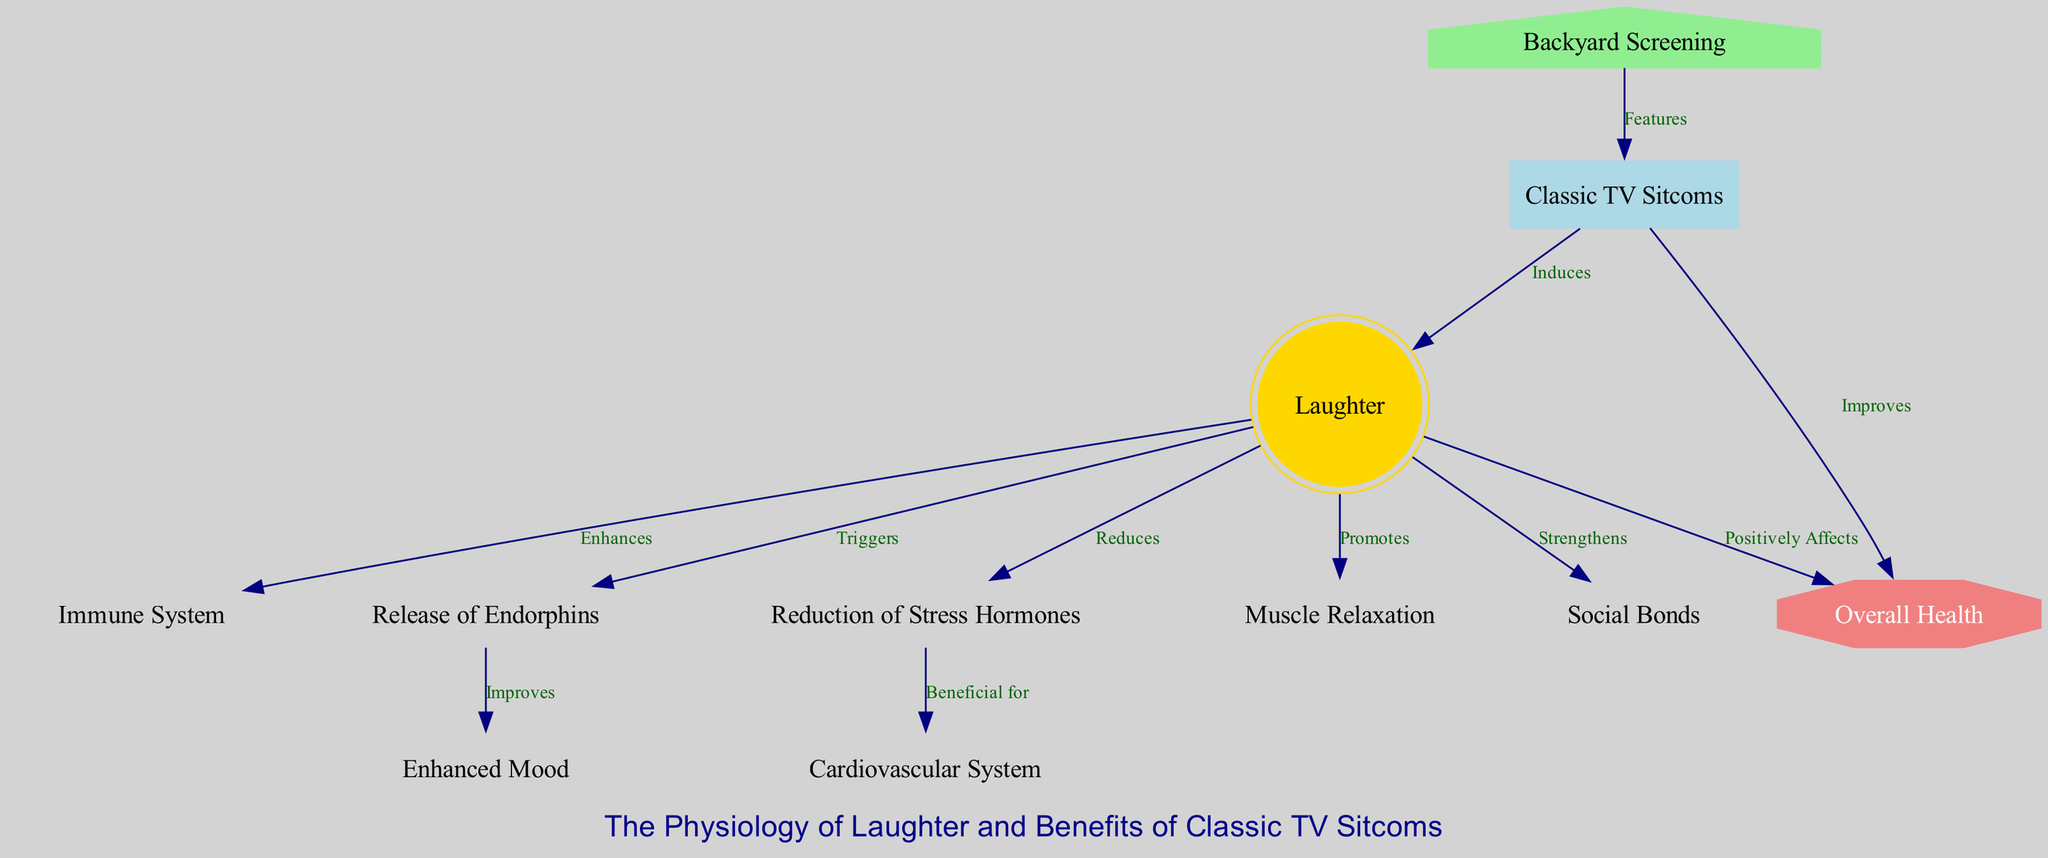What is the first node that is triggered by laughter? The diagram indicates that laughter triggers the release of endorphins, as represented by the edge from "laughter" to "endorphins."
Answer: Release of Endorphins How many total nodes are present in the diagram? By counting each node listed in the diagram, there are a total of 11 unique nodes.
Answer: 11 Which system benefits from the reduction of stress hormones? The diagram shows that stress hormones reduction is beneficial for the cardiovascular system, indicated by the edge from "stress" to "cardio."
Answer: Cardiovascular System What enhances immunity according to the diagram? As per the diagram, laughter enhances the immune system, as represented by the edge going from "laughter" to "immune."
Answer: Immune System What is the connection between classic TV sitcoms and laughter? The diagram shows that classic TV sitcoms induce laughter, represented by the edge from "sitcoms" to "laughter."
Answer: Induces Which aspect does watching classic TV sitcoms improve regarding overall health? The diagram indicates that classic TV sitcoms improve overall health, as shown by the edge from "sitcoms" to "overall_health."
Answer: Improves How does laughter affect social bonds? The diagram illustrates that laughter strengthens social bonds, indicated by the edge connecting "laughter" to "social."
Answer: Strengthens What promotes muscle relaxation? The diagram states that laughter promotes muscle relaxation, represented by the edge from "laughter" to "muscles."
Answer: Promotes What is featured in a backyard screening? According to the diagram, backyard screening features classic TV sitcoms, as illustrated by the edge from "backyard_screening" to "sitcoms."
Answer: Classic TV Sitcoms 